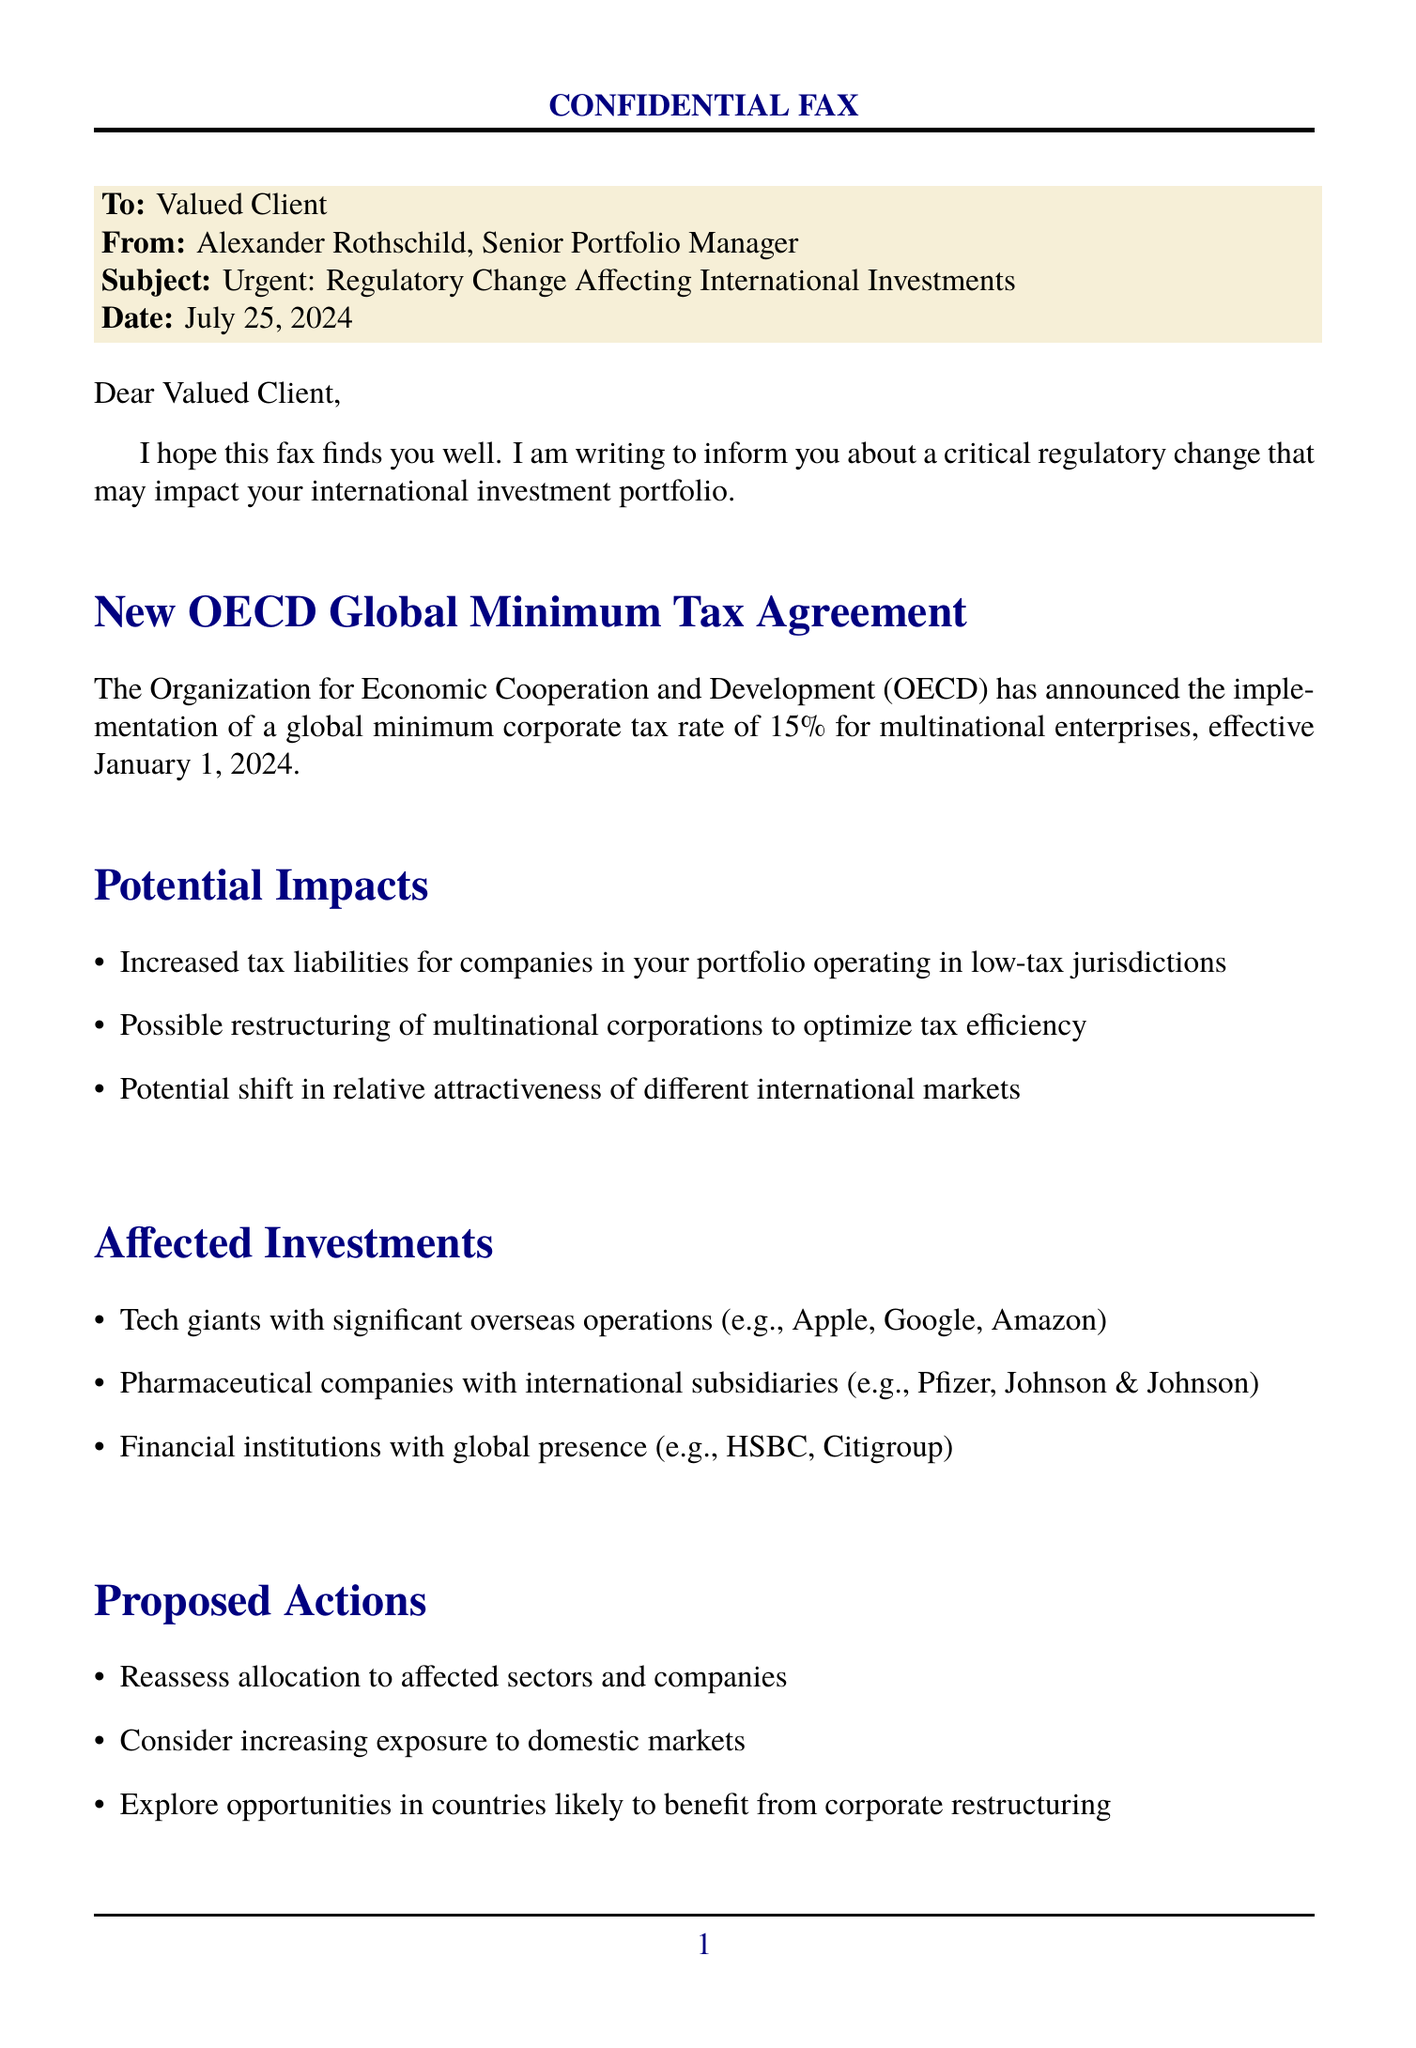What is the global minimum corporate tax rate announced by OECD? The document states that the OECD has announced a global minimum corporate tax rate of 15%.
Answer: 15% When does the new tax agreement become effective? The document mentions that the new tax agreement is effective January 1, 2024.
Answer: January 1, 2024 Which sector has increased tax liabilities due to the regulatory change? The document highlights that companies operating in low-tax jurisdictions will face increased tax liabilities.
Answer: Low-tax jurisdictions Who is the sender of this fax? The document identifies the sender as Alexander Rothschild, Senior Portfolio Manager.
Answer: Alexander Rothschild What companies are included in the affected investments? The fax lists companies like Apple, Google, Amazon, Pfizer, and HSBC among the affected investments.
Answer: Apple, Google, Amazon What is one proposed action regarding portfolio strategy? The document suggests reassessing allocation to affected sectors and companies as one proposed action.
Answer: Reassess allocation What type of meeting is proposed? The fax proposes a meeting to discuss the changes in detail and adjust the portfolio strategy.
Answer: Meeting How can the client arrange the meeting? The document provides a contact number for scheduling the meeting, which is +1 (212) 555-7890.
Answer: +1 (212) 555-7890 